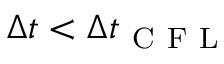<formula> <loc_0><loc_0><loc_500><loc_500>\Delta t < \Delta t _ { C F L }</formula> 